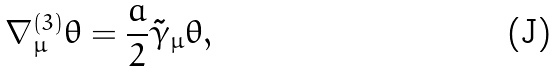<formula> <loc_0><loc_0><loc_500><loc_500>\nabla ^ { ( 3 ) } _ { \mu } \theta = \frac { a } { 2 } \tilde { \gamma } _ { \mu } \theta ,</formula> 